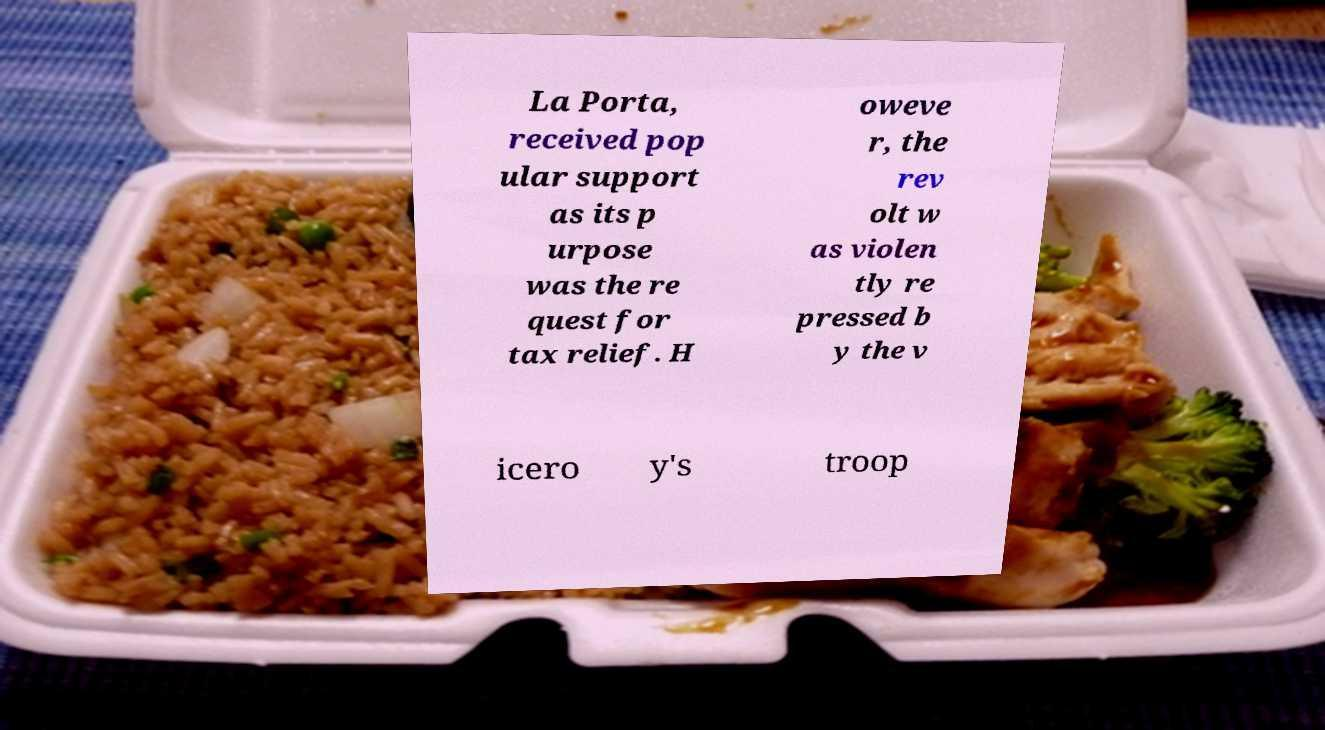For documentation purposes, I need the text within this image transcribed. Could you provide that? La Porta, received pop ular support as its p urpose was the re quest for tax relief. H oweve r, the rev olt w as violen tly re pressed b y the v icero y's troop 